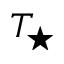<formula> <loc_0><loc_0><loc_500><loc_500>T _ { ^ { * } }</formula> 